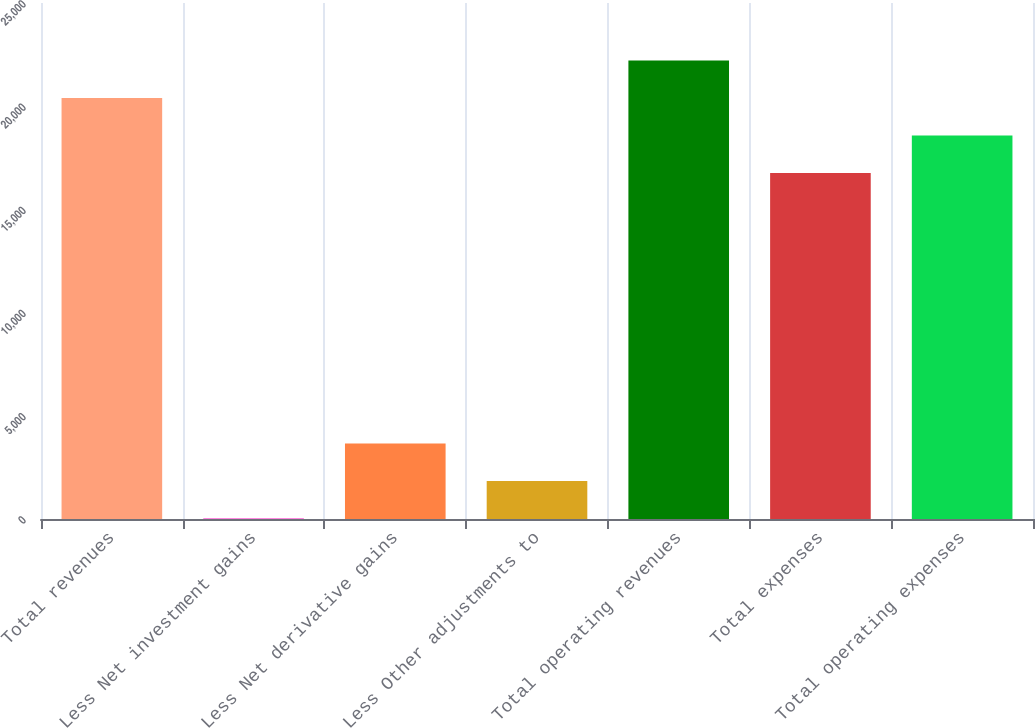Convert chart to OTSL. <chart><loc_0><loc_0><loc_500><loc_500><bar_chart><fcel>Total revenues<fcel>Less Net investment gains<fcel>Less Net derivative gains<fcel>Less Other adjustments to<fcel>Total operating revenues<fcel>Total expenses<fcel>Total operating expenses<nl><fcel>20394.6<fcel>21<fcel>3654.6<fcel>1837.8<fcel>22211.4<fcel>16761<fcel>18577.8<nl></chart> 